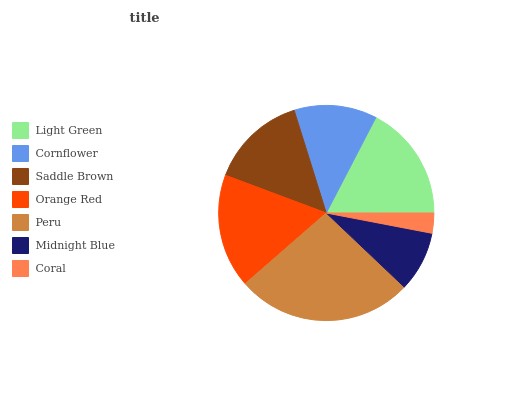Is Coral the minimum?
Answer yes or no. Yes. Is Peru the maximum?
Answer yes or no. Yes. Is Cornflower the minimum?
Answer yes or no. No. Is Cornflower the maximum?
Answer yes or no. No. Is Light Green greater than Cornflower?
Answer yes or no. Yes. Is Cornflower less than Light Green?
Answer yes or no. Yes. Is Cornflower greater than Light Green?
Answer yes or no. No. Is Light Green less than Cornflower?
Answer yes or no. No. Is Saddle Brown the high median?
Answer yes or no. Yes. Is Saddle Brown the low median?
Answer yes or no. Yes. Is Midnight Blue the high median?
Answer yes or no. No. Is Cornflower the low median?
Answer yes or no. No. 